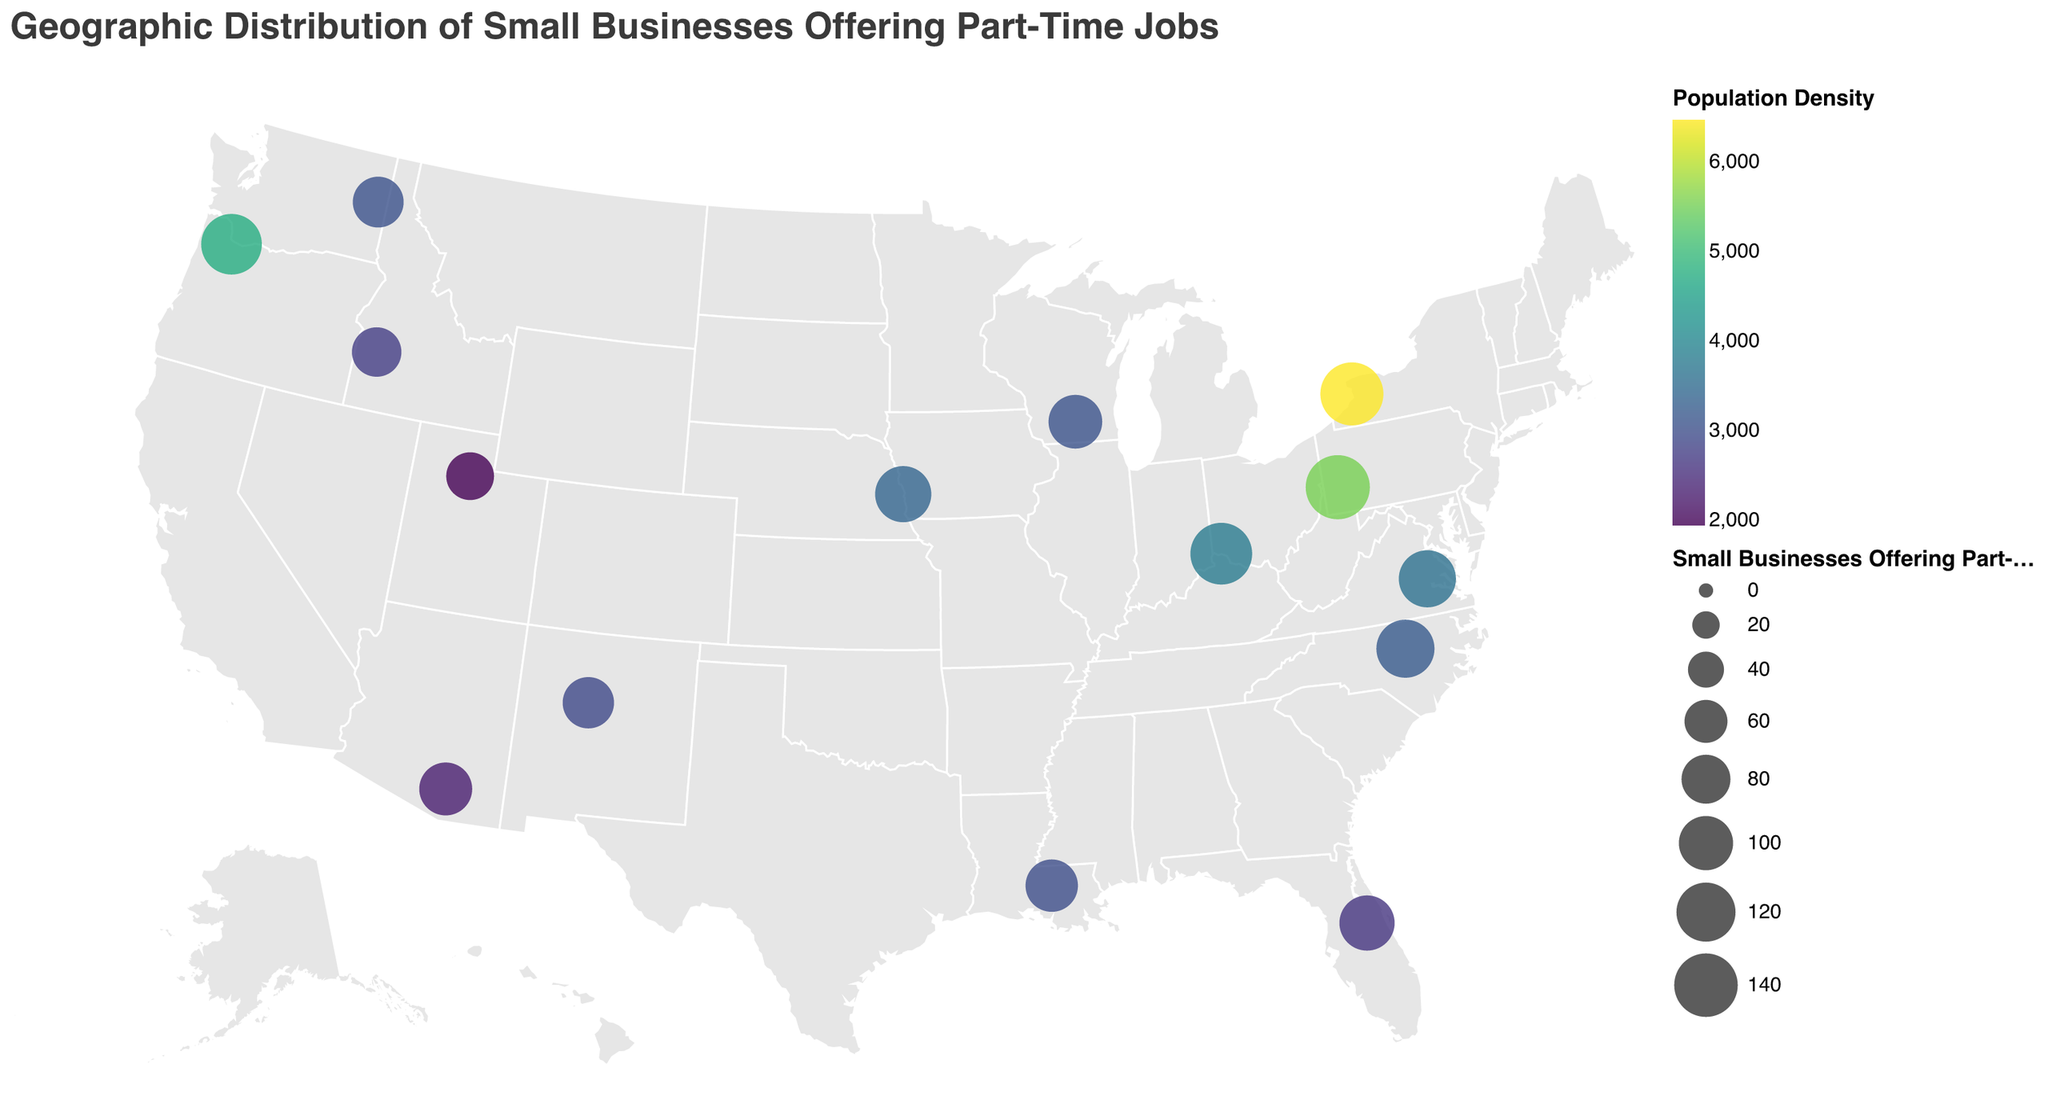What is the title of the figure? The title is usually found at the top of the plot. For this figure, it is clearly stated at the beginning.
Answer: Geographic Distribution of Small Businesses Offering Part-Time Jobs Which city has the highest number of small businesses offering part-time jobs? By looking at the size of the circles, we can identify the city with the largest circle. Larger circles represent a higher number of small businesses offering part-time jobs.
Answer: Pittsburgh What city has the highest population density? The color intensity in the viridis color scheme indicates the population density. The city with the darkest color will have the highest population density.
Answer: Buffalo Which city shows the lowest small businesses offering part-time jobs and what is its population density? The smallest circle will represent the lowest number, and looking at its color gives the population density.
Answer: Salt Lake City, 1940 Compare the number of small businesses offering part-time jobs between Raleigh and Omaha. Which city has more? By comparing the sizes of the circles for Raleigh and Omaha, we can determine which city has more small businesses offering part-time jobs.
Answer: Raleigh Which city has a higher population density, Baton Rouge or Boise? By comparing the color intensity for Baton Rouge and Boise, the city with the darker color will have the higher population density.
Answer: Baton Rouge What is the population density range of the cities included in the plot? To find the range, identify the lowest and highest color intensity values and find their corresponding numbers in the legend.
Answer: 1,940 to 6,470 Are there any cities that have both a high population density and a high number of small businesses offering part-time jobs? By looking at the plot, identify cities with large circles and dark, intense colors. These cities meet both criteria.
Answer: Pittsburgh and Buffalo Which city has more small businesses offering part-time jobs, Orlando or Richmond? Compare the sizes of the circles for Orlando and Richmond to see which is larger.
Answer: Orlando 